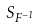<formula> <loc_0><loc_0><loc_500><loc_500>S _ { F ^ { - 1 } }</formula> 